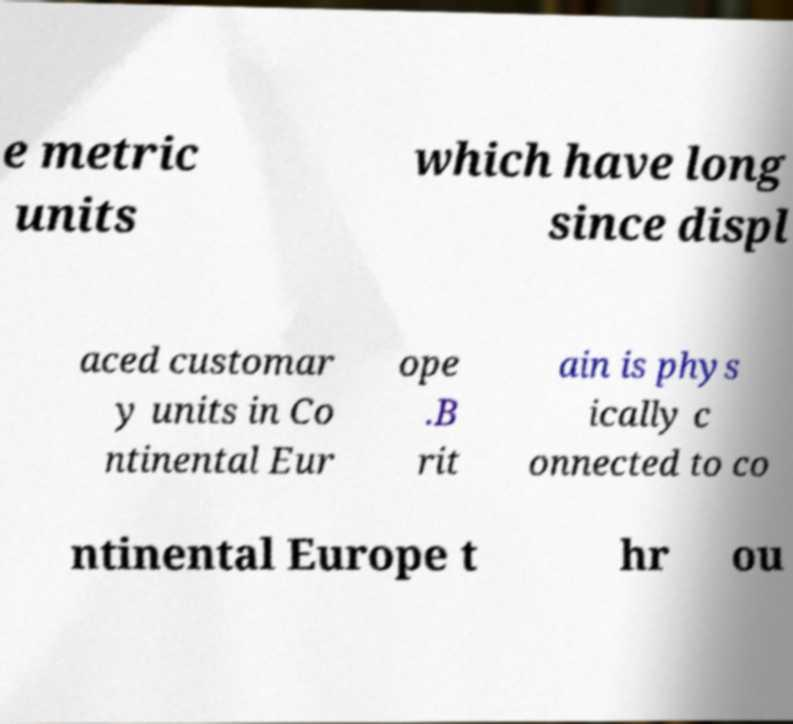Please identify and transcribe the text found in this image. e metric units which have long since displ aced customar y units in Co ntinental Eur ope .B rit ain is phys ically c onnected to co ntinental Europe t hr ou 